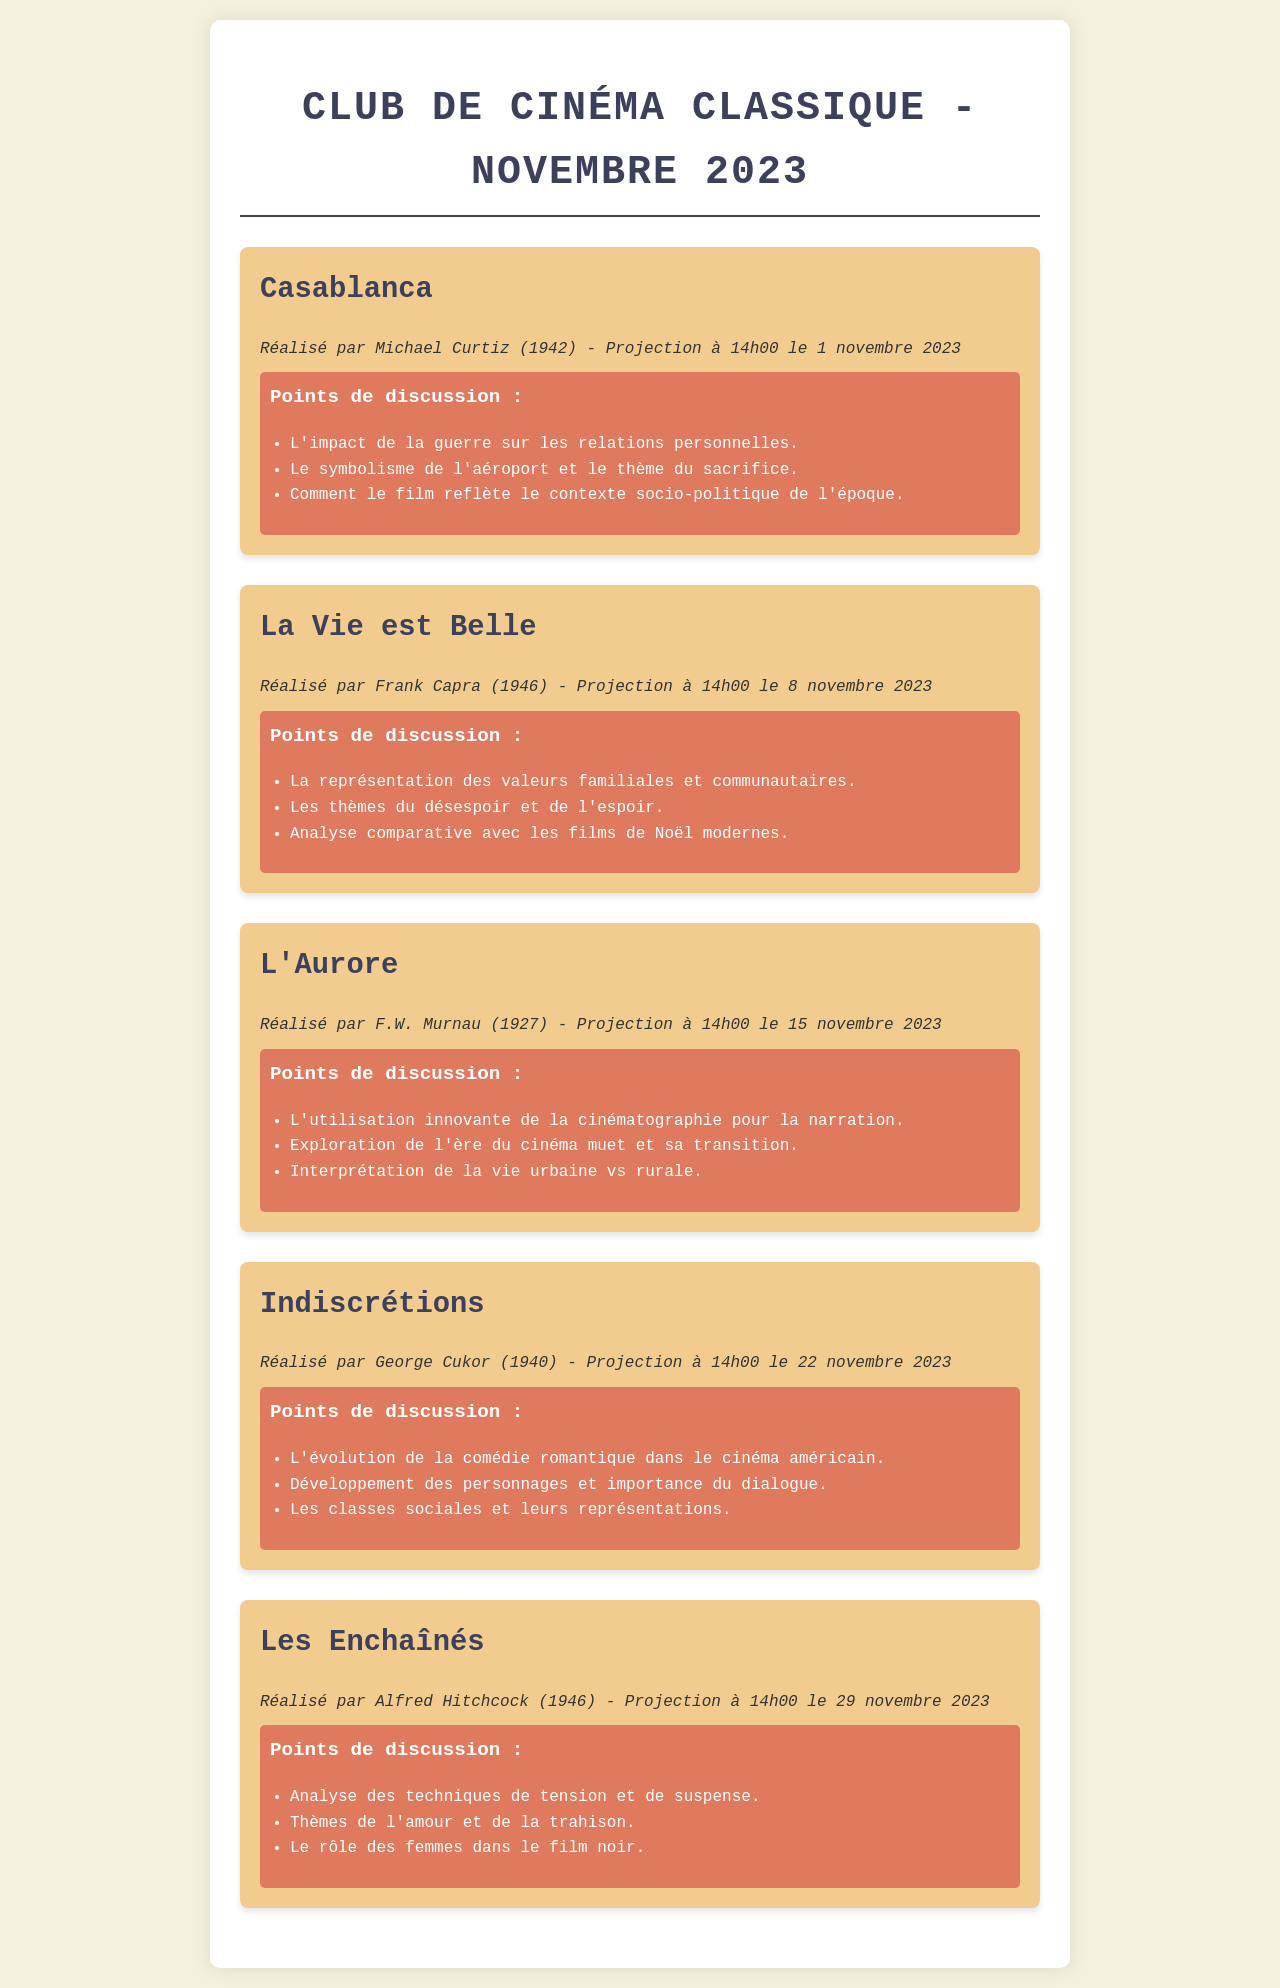Quel est le titre du premier film projeté ? Le premier film projeté est mentionné comme "Casablanca".
Answer: Casablanca À quelle heure est projeté "L'Aurore" ? L'heure de projection de "L'Aurore" est spécifiée comme 14h00.
Answer: 14h00 Qui a réalisé "Indiscrétions" ? Le réalisateur de "Indiscrétions" est indiqué comme George Cukor.
Answer: George Cukor Combien de films sont projetés en novembre ? Le nombre total de films projetés en novembre est précisé dans le document, ce qui est cinq.
Answer: cinq Quels sont les points de discussion pour "La Vie est Belle" ? Les éléments de discussion incluent des thèmes comme les valeurs familiales et communautaires, ainsi que l'espoir.
Answer: Valeurs familiales et communautaires Quel est le thème du dernier film, "Les Enchaînés" ? Les thèmes mentionnés pour "Les Enchaînés" incluent l'amour et la trahison.
Answer: Amour et trahison Quelle est la date de projection de "Casablanca" ? La date de projection de "Casablanca" est indiquée comme le 1 novembre 2023.
Answer: 1 novembre 2023 Quel réalisateur est associé à "La Vie est Belle" ? Le réalisateur de "La Vie est Belle" est précisé comme Frank Capra.
Answer: Frank Capra 